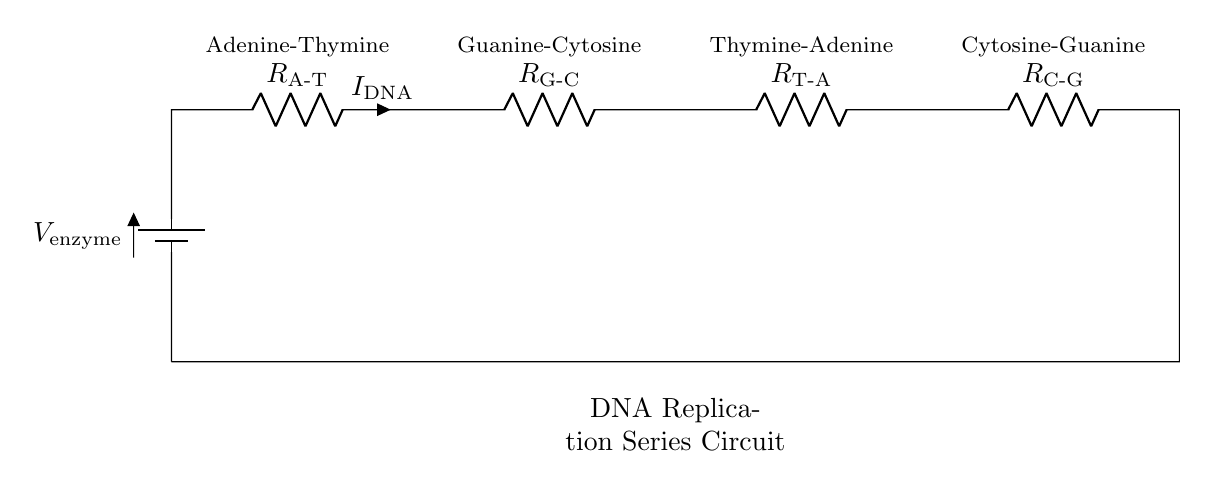What is the voltage source in this circuit? The voltage source is labeled as V enzyme, which provides the energy required for the process illustrated in the circuit.
Answer: V enzyme How many resistors are in this circuit? The circuit contains four resistors, which represent the four base pairs in DNA – Adenine-Thymine, Guanine-Cytosine, Thymine-Adenine, and Cytosine-Guanine.
Answer: Four What does the resistor labeled R A-T represent? The resistor labeled R A-T represents the Adenine-Thymine base pair, indicating the electrical characteristics of this pairing in the analogy to DNA replication.
Answer: Adenine-Thymine If the current in the circuit is 2 milliamperes, what does it signify? A current of 2 milliamperes signifies the flow of 'DNA' current through the series circuit, analogous to the replication process occurring in the DNA strand.
Answer: Two milliamperes Which base pair has the highest resistance according to this circuit? The circuit does not provide specific resistance values, but it indicates the resistance relative to base pairs; if one were to analyze standard values, Guanine-Cytosine typically has higher stability and thus could be inferred to embody higher resistance than other pairs.
Answer: Guanine-Cytosine Is this circuit a series or parallel circuit? The circuit is a series circuit since all components are connected end-to-end along a single path, which affects the total resistance and current flow.
Answer: Series What is the function of the resistors in this model? The resistors represent the base pairs in the DNA structure, modeling their effects on current flow and the energy necessary for competitive binding in replication.
Answer: Represent base pairs 